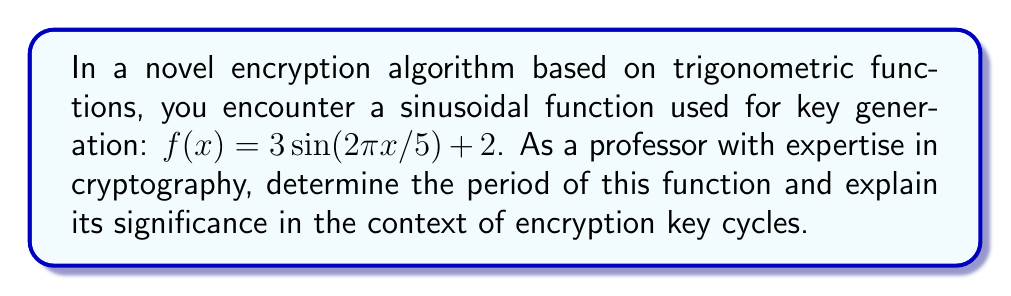Could you help me with this problem? To determine the period of the given trigonometric function, we need to analyze its components:

1. The general form of a sine function is $a\sin(bx) + c$, where $b$ affects the period.

2. In our case, $f(x) = 3\sin(2\pi x/5) + 2$, so we focus on the argument of sine: $2\pi x/5$.

3. The period of $\sin(x)$ is $2\pi$. To find the period of our function, we set:

   $$2\pi x/5 = 2\pi$$

4. Solving for $x$:
   $$x/5 = 1$$
   $$x = 5$$

5. Therefore, the period of the function is 5.

In the context of encryption and key cycles:

- The period represents the interval after which the function's values repeat.
- For cryptographic purposes, this means the key generation pattern would repeat every 5 units.
- In practice, this could correspond to time intervals, input values, or iteration counts in the key generation process.
- A shorter period (like 5) might be considered less secure as it introduces more predictability into the system.
- Cryptographically strong systems often use functions with very long periods or aperiodic functions to enhance security.

Understanding this period is crucial for assessing the strength and potential vulnerabilities of the encryption algorithm, especially in relation to key generation and cycle lengths in cryptographic protocols.
Answer: The period of the function $f(x) = 3\sin(2\pi x/5) + 2$ is 5. 